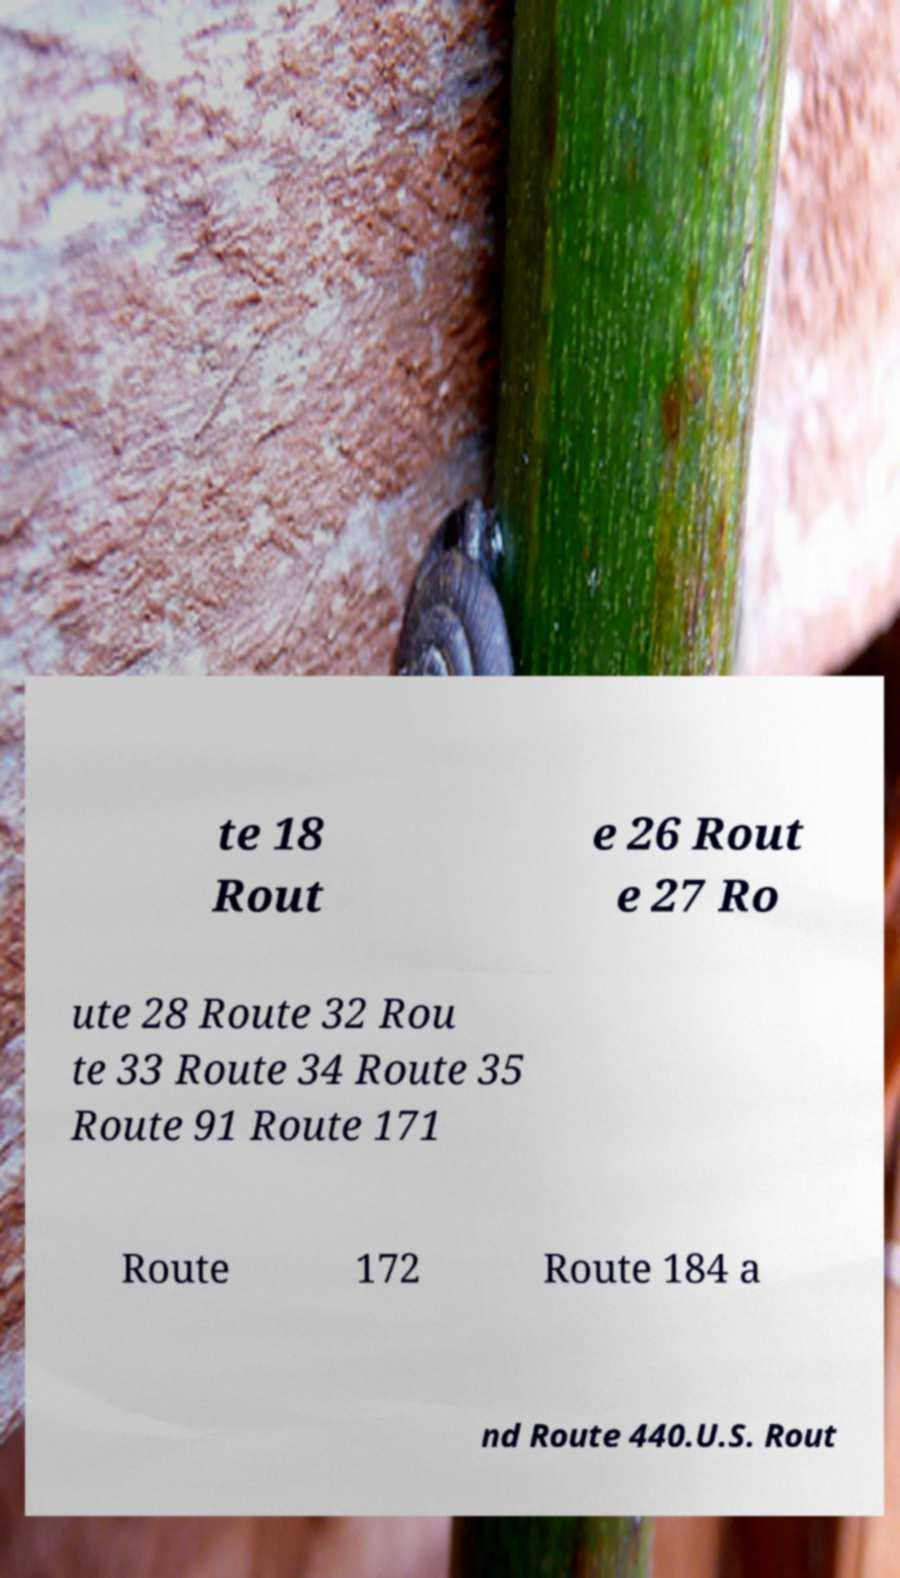For documentation purposes, I need the text within this image transcribed. Could you provide that? te 18 Rout e 26 Rout e 27 Ro ute 28 Route 32 Rou te 33 Route 34 Route 35 Route 91 Route 171 Route 172 Route 184 a nd Route 440.U.S. Rout 